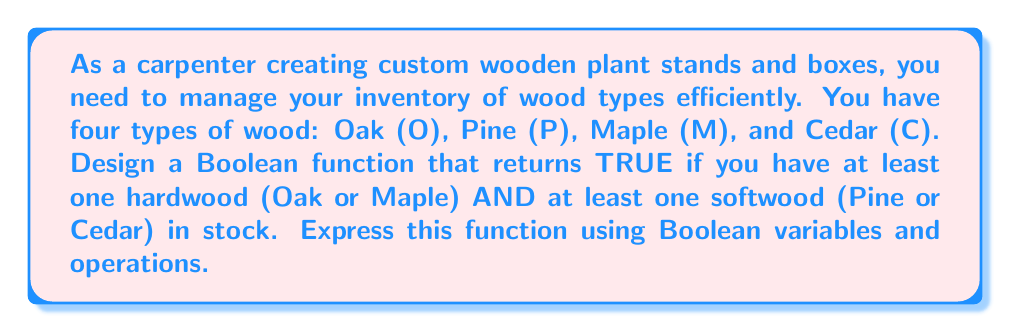Can you solve this math problem? Let's approach this step-by-step:

1) Define Boolean variables for each wood type:
   $O$ = Oak in stock (1 if true, 0 if false)
   $P$ = Pine in stock
   $M$ = Maple in stock
   $C$ = Cedar in stock

2) We need to express "at least one hardwood":
   This is true if either Oak OR Maple is in stock.
   In Boolean algebra, this is written as: $O + M$

3) Similarly, for "at least one softwood":
   This is true if either Pine OR Cedar is in stock.
   In Boolean algebra: $P + C$

4) The inventory management system should return TRUE if BOTH conditions are met:
   We have (at least one hardwood) AND (at least one softwood)

5) In Boolean algebra, AND is represented by multiplication. So our final function is:

   $F = (O + M)(P + C)$

This Boolean function will return TRUE (1) if there is at least one hardwood AND at least one softwood in stock, and FALSE (0) otherwise.
Answer: $F = (O + M)(P + C)$ 